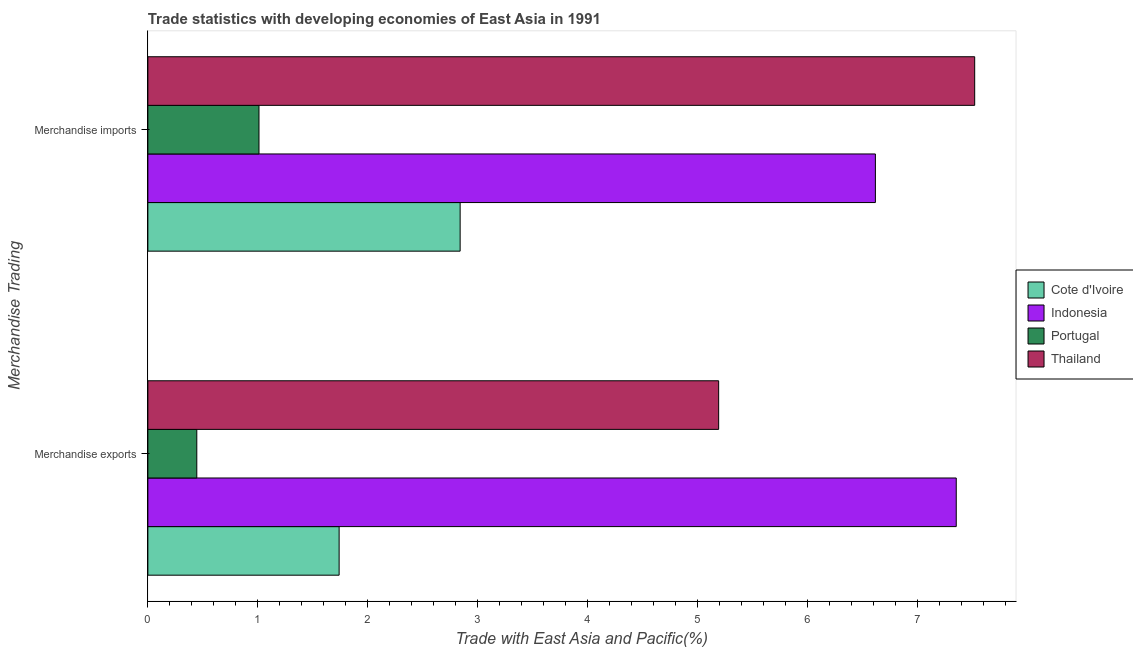How many groups of bars are there?
Give a very brief answer. 2. Are the number of bars on each tick of the Y-axis equal?
Make the answer very short. Yes. How many bars are there on the 2nd tick from the top?
Provide a short and direct response. 4. How many bars are there on the 1st tick from the bottom?
Your response must be concise. 4. What is the merchandise imports in Thailand?
Offer a terse response. 7.52. Across all countries, what is the maximum merchandise exports?
Provide a short and direct response. 7.35. Across all countries, what is the minimum merchandise imports?
Your response must be concise. 1.01. In which country was the merchandise exports maximum?
Your response must be concise. Indonesia. In which country was the merchandise imports minimum?
Offer a very short reply. Portugal. What is the total merchandise exports in the graph?
Give a very brief answer. 14.73. What is the difference between the merchandise imports in Thailand and that in Portugal?
Make the answer very short. 6.51. What is the difference between the merchandise exports in Portugal and the merchandise imports in Indonesia?
Give a very brief answer. -6.17. What is the average merchandise exports per country?
Offer a terse response. 3.68. What is the difference between the merchandise imports and merchandise exports in Indonesia?
Offer a very short reply. -0.74. What is the ratio of the merchandise exports in Portugal to that in Cote d'Ivoire?
Provide a succinct answer. 0.26. In how many countries, is the merchandise imports greater than the average merchandise imports taken over all countries?
Provide a short and direct response. 2. What does the 1st bar from the top in Merchandise exports represents?
Provide a succinct answer. Thailand. What does the 1st bar from the bottom in Merchandise imports represents?
Provide a short and direct response. Cote d'Ivoire. Are all the bars in the graph horizontal?
Make the answer very short. Yes. How many countries are there in the graph?
Your answer should be very brief. 4. What is the difference between two consecutive major ticks on the X-axis?
Give a very brief answer. 1. Does the graph contain any zero values?
Provide a succinct answer. No. Does the graph contain grids?
Offer a very short reply. No. What is the title of the graph?
Offer a very short reply. Trade statistics with developing economies of East Asia in 1991. Does "Bolivia" appear as one of the legend labels in the graph?
Give a very brief answer. No. What is the label or title of the X-axis?
Offer a very short reply. Trade with East Asia and Pacific(%). What is the label or title of the Y-axis?
Give a very brief answer. Merchandise Trading. What is the Trade with East Asia and Pacific(%) in Cote d'Ivoire in Merchandise exports?
Your answer should be very brief. 1.74. What is the Trade with East Asia and Pacific(%) in Indonesia in Merchandise exports?
Provide a succinct answer. 7.35. What is the Trade with East Asia and Pacific(%) of Portugal in Merchandise exports?
Give a very brief answer. 0.45. What is the Trade with East Asia and Pacific(%) of Thailand in Merchandise exports?
Offer a terse response. 5.19. What is the Trade with East Asia and Pacific(%) of Cote d'Ivoire in Merchandise imports?
Make the answer very short. 2.84. What is the Trade with East Asia and Pacific(%) in Indonesia in Merchandise imports?
Your answer should be very brief. 6.62. What is the Trade with East Asia and Pacific(%) of Portugal in Merchandise imports?
Offer a terse response. 1.01. What is the Trade with East Asia and Pacific(%) in Thailand in Merchandise imports?
Provide a short and direct response. 7.52. Across all Merchandise Trading, what is the maximum Trade with East Asia and Pacific(%) in Cote d'Ivoire?
Your answer should be very brief. 2.84. Across all Merchandise Trading, what is the maximum Trade with East Asia and Pacific(%) in Indonesia?
Make the answer very short. 7.35. Across all Merchandise Trading, what is the maximum Trade with East Asia and Pacific(%) in Portugal?
Your answer should be compact. 1.01. Across all Merchandise Trading, what is the maximum Trade with East Asia and Pacific(%) of Thailand?
Offer a terse response. 7.52. Across all Merchandise Trading, what is the minimum Trade with East Asia and Pacific(%) in Cote d'Ivoire?
Keep it short and to the point. 1.74. Across all Merchandise Trading, what is the minimum Trade with East Asia and Pacific(%) of Indonesia?
Your response must be concise. 6.62. Across all Merchandise Trading, what is the minimum Trade with East Asia and Pacific(%) of Portugal?
Give a very brief answer. 0.45. Across all Merchandise Trading, what is the minimum Trade with East Asia and Pacific(%) in Thailand?
Provide a succinct answer. 5.19. What is the total Trade with East Asia and Pacific(%) in Cote d'Ivoire in the graph?
Make the answer very short. 4.58. What is the total Trade with East Asia and Pacific(%) in Indonesia in the graph?
Give a very brief answer. 13.97. What is the total Trade with East Asia and Pacific(%) of Portugal in the graph?
Your answer should be very brief. 1.46. What is the total Trade with East Asia and Pacific(%) of Thailand in the graph?
Your response must be concise. 12.72. What is the difference between the Trade with East Asia and Pacific(%) of Cote d'Ivoire in Merchandise exports and that in Merchandise imports?
Your response must be concise. -1.1. What is the difference between the Trade with East Asia and Pacific(%) of Indonesia in Merchandise exports and that in Merchandise imports?
Ensure brevity in your answer.  0.74. What is the difference between the Trade with East Asia and Pacific(%) in Portugal in Merchandise exports and that in Merchandise imports?
Offer a terse response. -0.57. What is the difference between the Trade with East Asia and Pacific(%) of Thailand in Merchandise exports and that in Merchandise imports?
Provide a short and direct response. -2.33. What is the difference between the Trade with East Asia and Pacific(%) of Cote d'Ivoire in Merchandise exports and the Trade with East Asia and Pacific(%) of Indonesia in Merchandise imports?
Keep it short and to the point. -4.88. What is the difference between the Trade with East Asia and Pacific(%) of Cote d'Ivoire in Merchandise exports and the Trade with East Asia and Pacific(%) of Portugal in Merchandise imports?
Your response must be concise. 0.73. What is the difference between the Trade with East Asia and Pacific(%) of Cote d'Ivoire in Merchandise exports and the Trade with East Asia and Pacific(%) of Thailand in Merchandise imports?
Make the answer very short. -5.78. What is the difference between the Trade with East Asia and Pacific(%) in Indonesia in Merchandise exports and the Trade with East Asia and Pacific(%) in Portugal in Merchandise imports?
Give a very brief answer. 6.34. What is the difference between the Trade with East Asia and Pacific(%) in Indonesia in Merchandise exports and the Trade with East Asia and Pacific(%) in Thailand in Merchandise imports?
Your response must be concise. -0.17. What is the difference between the Trade with East Asia and Pacific(%) of Portugal in Merchandise exports and the Trade with East Asia and Pacific(%) of Thailand in Merchandise imports?
Provide a succinct answer. -7.08. What is the average Trade with East Asia and Pacific(%) of Cote d'Ivoire per Merchandise Trading?
Offer a very short reply. 2.29. What is the average Trade with East Asia and Pacific(%) in Indonesia per Merchandise Trading?
Offer a terse response. 6.99. What is the average Trade with East Asia and Pacific(%) in Portugal per Merchandise Trading?
Offer a terse response. 0.73. What is the average Trade with East Asia and Pacific(%) in Thailand per Merchandise Trading?
Keep it short and to the point. 6.36. What is the difference between the Trade with East Asia and Pacific(%) in Cote d'Ivoire and Trade with East Asia and Pacific(%) in Indonesia in Merchandise exports?
Give a very brief answer. -5.61. What is the difference between the Trade with East Asia and Pacific(%) of Cote d'Ivoire and Trade with East Asia and Pacific(%) of Portugal in Merchandise exports?
Your response must be concise. 1.29. What is the difference between the Trade with East Asia and Pacific(%) in Cote d'Ivoire and Trade with East Asia and Pacific(%) in Thailand in Merchandise exports?
Your response must be concise. -3.45. What is the difference between the Trade with East Asia and Pacific(%) of Indonesia and Trade with East Asia and Pacific(%) of Portugal in Merchandise exports?
Make the answer very short. 6.91. What is the difference between the Trade with East Asia and Pacific(%) in Indonesia and Trade with East Asia and Pacific(%) in Thailand in Merchandise exports?
Offer a very short reply. 2.16. What is the difference between the Trade with East Asia and Pacific(%) in Portugal and Trade with East Asia and Pacific(%) in Thailand in Merchandise exports?
Ensure brevity in your answer.  -4.75. What is the difference between the Trade with East Asia and Pacific(%) of Cote d'Ivoire and Trade with East Asia and Pacific(%) of Indonesia in Merchandise imports?
Your response must be concise. -3.78. What is the difference between the Trade with East Asia and Pacific(%) in Cote d'Ivoire and Trade with East Asia and Pacific(%) in Portugal in Merchandise imports?
Your response must be concise. 1.83. What is the difference between the Trade with East Asia and Pacific(%) in Cote d'Ivoire and Trade with East Asia and Pacific(%) in Thailand in Merchandise imports?
Ensure brevity in your answer.  -4.68. What is the difference between the Trade with East Asia and Pacific(%) in Indonesia and Trade with East Asia and Pacific(%) in Portugal in Merchandise imports?
Ensure brevity in your answer.  5.61. What is the difference between the Trade with East Asia and Pacific(%) in Indonesia and Trade with East Asia and Pacific(%) in Thailand in Merchandise imports?
Your answer should be very brief. -0.9. What is the difference between the Trade with East Asia and Pacific(%) of Portugal and Trade with East Asia and Pacific(%) of Thailand in Merchandise imports?
Keep it short and to the point. -6.51. What is the ratio of the Trade with East Asia and Pacific(%) in Cote d'Ivoire in Merchandise exports to that in Merchandise imports?
Give a very brief answer. 0.61. What is the ratio of the Trade with East Asia and Pacific(%) of Indonesia in Merchandise exports to that in Merchandise imports?
Provide a succinct answer. 1.11. What is the ratio of the Trade with East Asia and Pacific(%) in Portugal in Merchandise exports to that in Merchandise imports?
Make the answer very short. 0.44. What is the ratio of the Trade with East Asia and Pacific(%) of Thailand in Merchandise exports to that in Merchandise imports?
Your response must be concise. 0.69. What is the difference between the highest and the second highest Trade with East Asia and Pacific(%) in Cote d'Ivoire?
Offer a very short reply. 1.1. What is the difference between the highest and the second highest Trade with East Asia and Pacific(%) in Indonesia?
Keep it short and to the point. 0.74. What is the difference between the highest and the second highest Trade with East Asia and Pacific(%) in Portugal?
Offer a very short reply. 0.57. What is the difference between the highest and the second highest Trade with East Asia and Pacific(%) of Thailand?
Offer a terse response. 2.33. What is the difference between the highest and the lowest Trade with East Asia and Pacific(%) in Cote d'Ivoire?
Your answer should be compact. 1.1. What is the difference between the highest and the lowest Trade with East Asia and Pacific(%) of Indonesia?
Keep it short and to the point. 0.74. What is the difference between the highest and the lowest Trade with East Asia and Pacific(%) of Portugal?
Make the answer very short. 0.57. What is the difference between the highest and the lowest Trade with East Asia and Pacific(%) in Thailand?
Offer a very short reply. 2.33. 